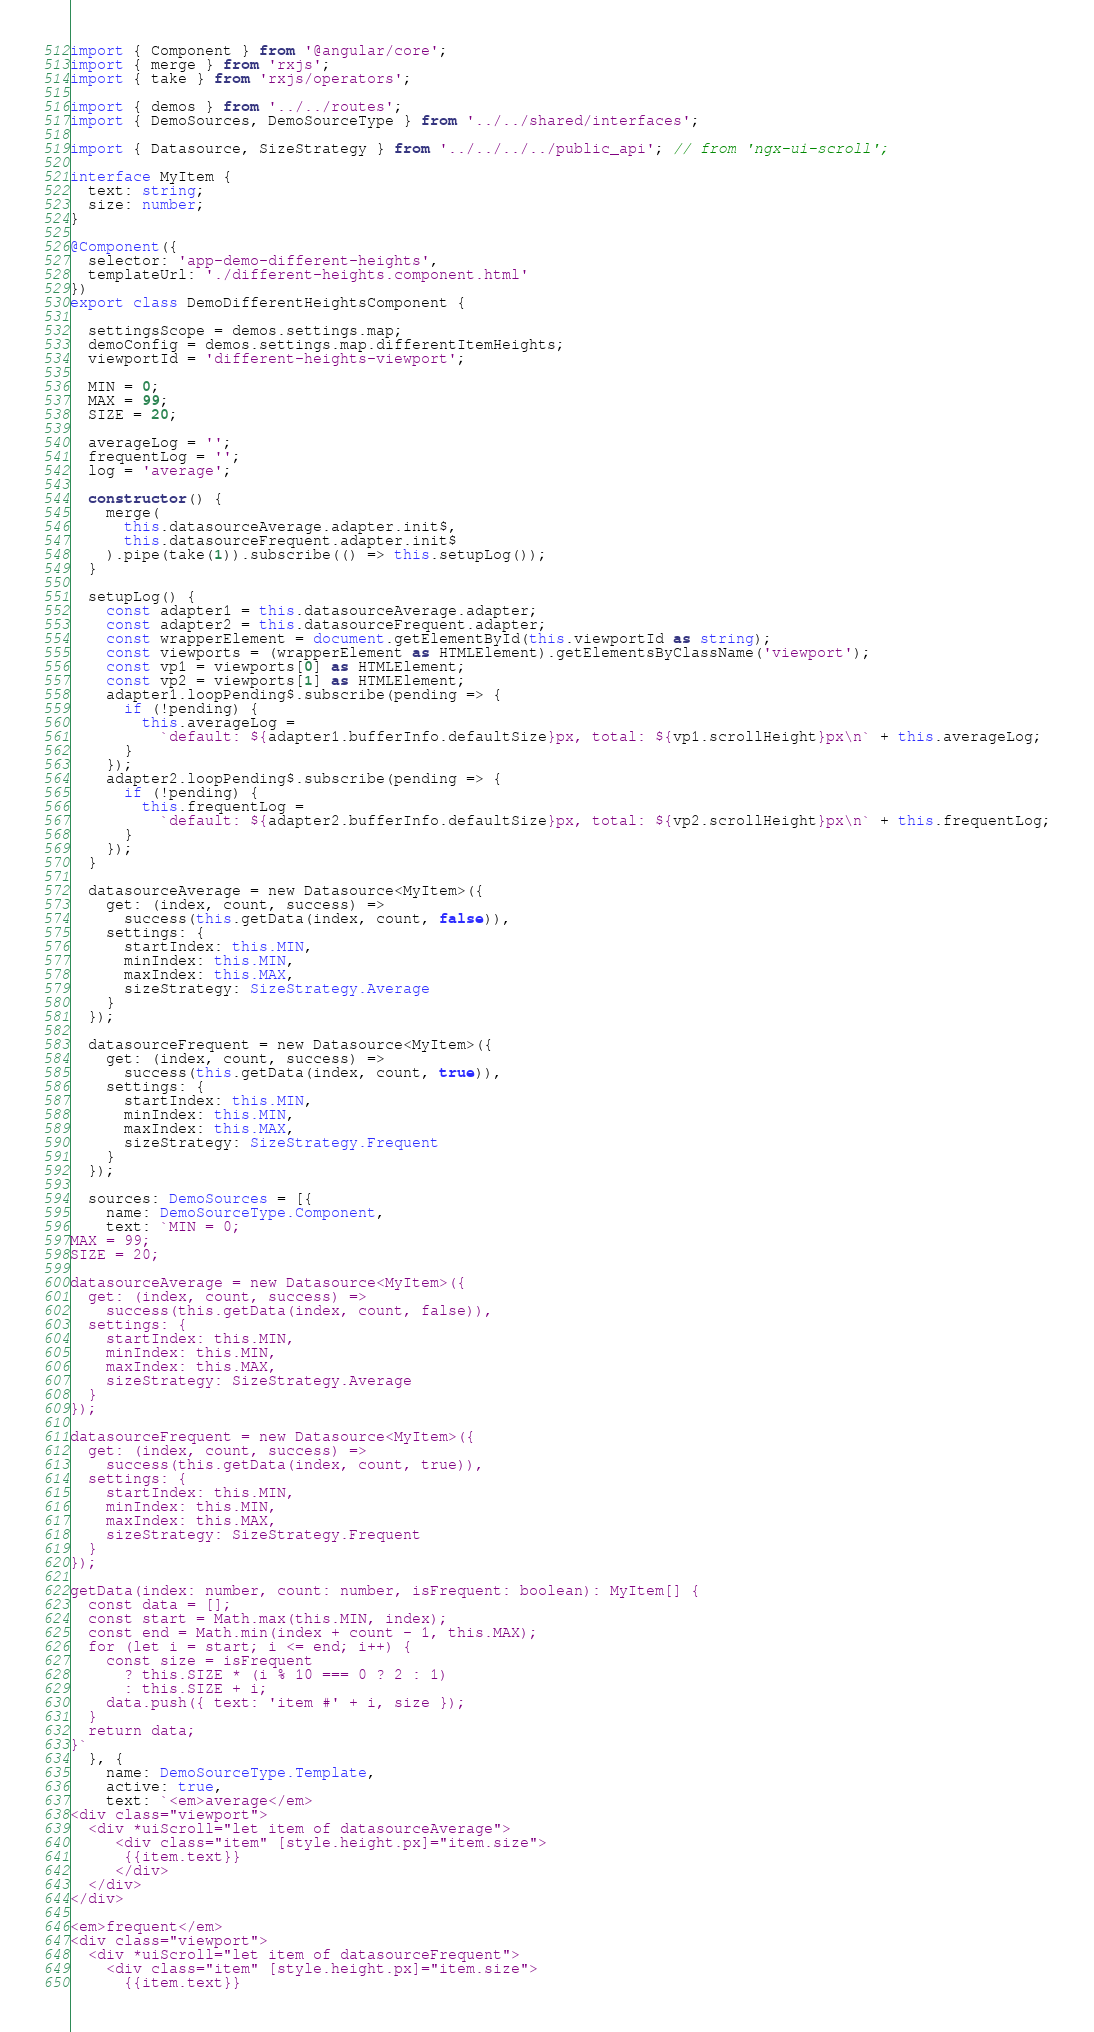<code> <loc_0><loc_0><loc_500><loc_500><_TypeScript_>import { Component } from '@angular/core';
import { merge } from 'rxjs';
import { take } from 'rxjs/operators';

import { demos } from '../../routes';
import { DemoSources, DemoSourceType } from '../../shared/interfaces';

import { Datasource, SizeStrategy } from '../../../../public_api'; // from 'ngx-ui-scroll';

interface MyItem {
  text: string;
  size: number;
}

@Component({
  selector: 'app-demo-different-heights',
  templateUrl: './different-heights.component.html'
})
export class DemoDifferentHeightsComponent {

  settingsScope = demos.settings.map;
  demoConfig = demos.settings.map.differentItemHeights;
  viewportId = 'different-heights-viewport';

  MIN = 0;
  MAX = 99;
  SIZE = 20;

  averageLog = '';
  frequentLog = '';
  log = 'average';

  constructor() {
    merge(
      this.datasourceAverage.adapter.init$,
      this.datasourceFrequent.adapter.init$
    ).pipe(take(1)).subscribe(() => this.setupLog());
  }

  setupLog() {
    const adapter1 = this.datasourceAverage.adapter;
    const adapter2 = this.datasourceFrequent.adapter;
    const wrapperElement = document.getElementById(this.viewportId as string);
    const viewports = (wrapperElement as HTMLElement).getElementsByClassName('viewport');
    const vp1 = viewports[0] as HTMLElement;
    const vp2 = viewports[1] as HTMLElement;
    adapter1.loopPending$.subscribe(pending => {
      if (!pending) {
        this.averageLog =
          `default: ${adapter1.bufferInfo.defaultSize}px, total: ${vp1.scrollHeight}px\n` + this.averageLog;
      }
    });
    adapter2.loopPending$.subscribe(pending => {
      if (!pending) {
        this.frequentLog =
          `default: ${adapter2.bufferInfo.defaultSize}px, total: ${vp2.scrollHeight}px\n` + this.frequentLog;
      }
    });
  }

  datasourceAverage = new Datasource<MyItem>({
    get: (index, count, success) =>
      success(this.getData(index, count, false)),
    settings: {
      startIndex: this.MIN,
      minIndex: this.MIN,
      maxIndex: this.MAX,
      sizeStrategy: SizeStrategy.Average
    }
  });

  datasourceFrequent = new Datasource<MyItem>({
    get: (index, count, success) =>
      success(this.getData(index, count, true)),
    settings: {
      startIndex: this.MIN,
      minIndex: this.MIN,
      maxIndex: this.MAX,
      sizeStrategy: SizeStrategy.Frequent
    }
  });

  sources: DemoSources = [{
    name: DemoSourceType.Component,
    text: `MIN = 0;
MAX = 99;
SIZE = 20;

datasourceAverage = new Datasource<MyItem>({
  get: (index, count, success) =>
    success(this.getData(index, count, false)),
  settings: {
    startIndex: this.MIN,
    minIndex: this.MIN,
    maxIndex: this.MAX,
    sizeStrategy: SizeStrategy.Average
  }
});

datasourceFrequent = new Datasource<MyItem>({
  get: (index, count, success) =>
    success(this.getData(index, count, true)),
  settings: {
    startIndex: this.MIN,
    minIndex: this.MIN,
    maxIndex: this.MAX,
    sizeStrategy: SizeStrategy.Frequent
  }
});

getData(index: number, count: number, isFrequent: boolean): MyItem[] {
  const data = [];
  const start = Math.max(this.MIN, index);
  const end = Math.min(index + count - 1, this.MAX);
  for (let i = start; i <= end; i++) {
    const size = isFrequent
      ? this.SIZE * (i % 10 === 0 ? 2 : 1)
      : this.SIZE + i;
    data.push({ text: 'item #' + i, size });
  }
  return data;
}`
  }, {
    name: DemoSourceType.Template,
    active: true,
    text: `<em>average</em>
<div class="viewport">
  <div *uiScroll="let item of datasourceAverage">
     <div class="item" [style.height.px]="item.size">
      {{item.text}}
     </div>
  </div>
</div>

<em>frequent</em>
<div class="viewport">
  <div *uiScroll="let item of datasourceFrequent">
    <div class="item" [style.height.px]="item.size">
      {{item.text}}</code> 